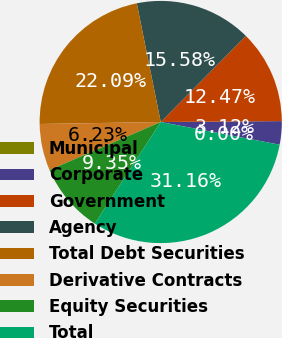Convert chart to OTSL. <chart><loc_0><loc_0><loc_500><loc_500><pie_chart><fcel>Municipal<fcel>Corporate<fcel>Government<fcel>Agency<fcel>Total Debt Securities<fcel>Derivative Contracts<fcel>Equity Securities<fcel>Total<nl><fcel>0.0%<fcel>3.12%<fcel>12.47%<fcel>15.58%<fcel>22.09%<fcel>6.23%<fcel>9.35%<fcel>31.16%<nl></chart> 